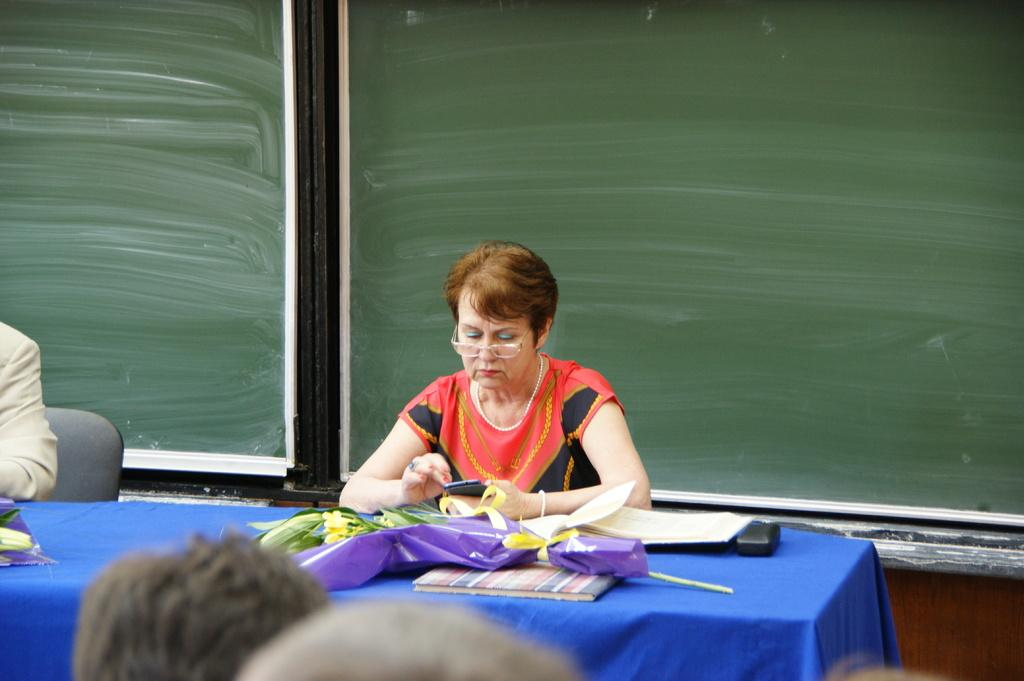Who is the main subject in the image? There is a woman in the image. What is the woman doing in the image? The woman is seated on a chair and holding a mobile. What else can be seen on the table in the image? There is a book and flowers on the table. Are there any other people present in the image? Yes, there are people seated on the side. What type of test is being conducted in the image? There is no test being conducted in the image; it features a woman seated on a chair holding a mobile. What kind of steel is used to make the chair in the image? The image does not provide information about the material used to make the chair, and there is no indication that steel is involved. 